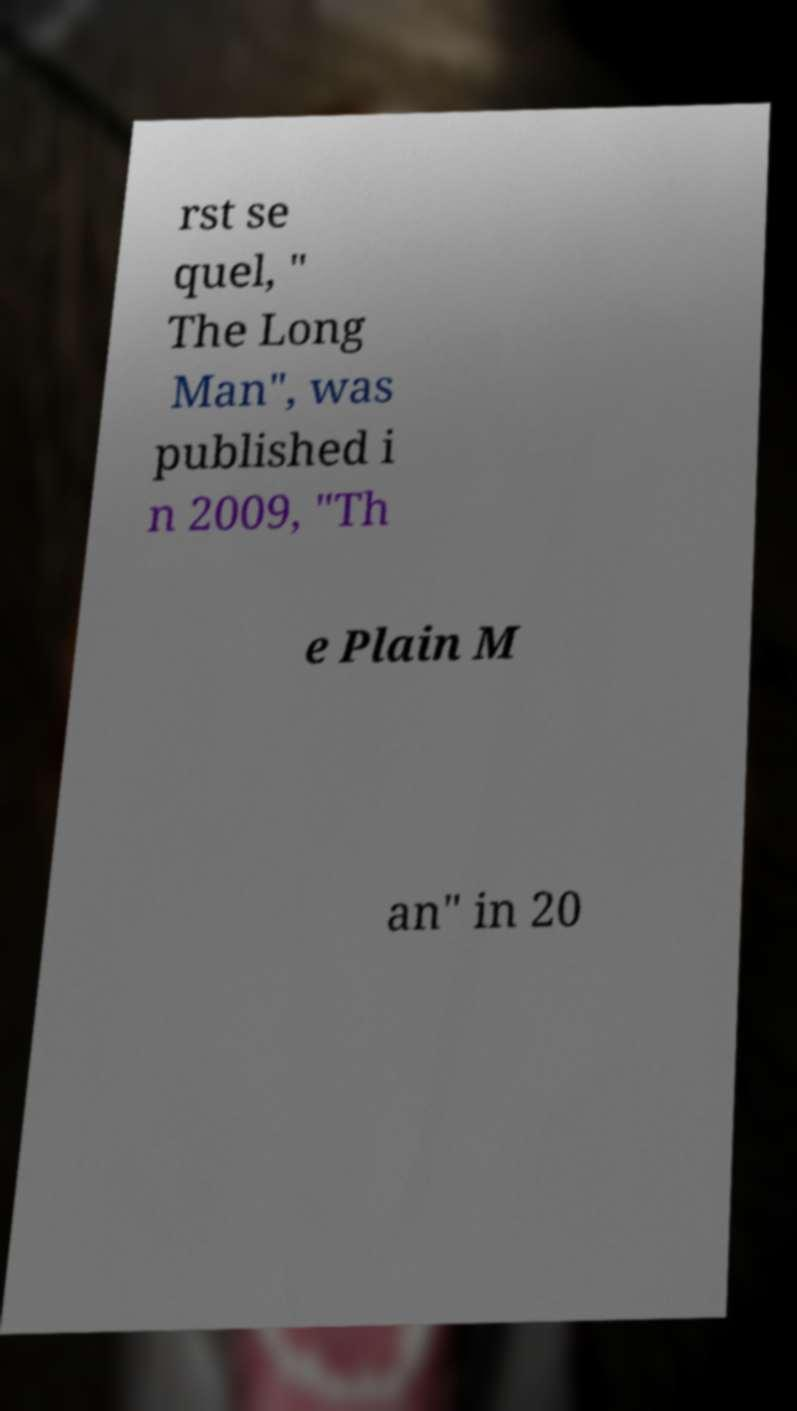For documentation purposes, I need the text within this image transcribed. Could you provide that? rst se quel, " The Long Man", was published i n 2009, "Th e Plain M an" in 20 